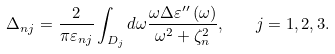Convert formula to latex. <formula><loc_0><loc_0><loc_500><loc_500>\Delta _ { n j } = \frac { 2 } { \pi \varepsilon _ { n j } } \int _ { D _ { j } } d \omega \frac { \omega \Delta \varepsilon ^ { \prime \prime } \left ( \omega \right ) } { \omega ^ { 2 } + \zeta _ { n } ^ { 2 } } , \quad j = 1 , 2 , 3 .</formula> 